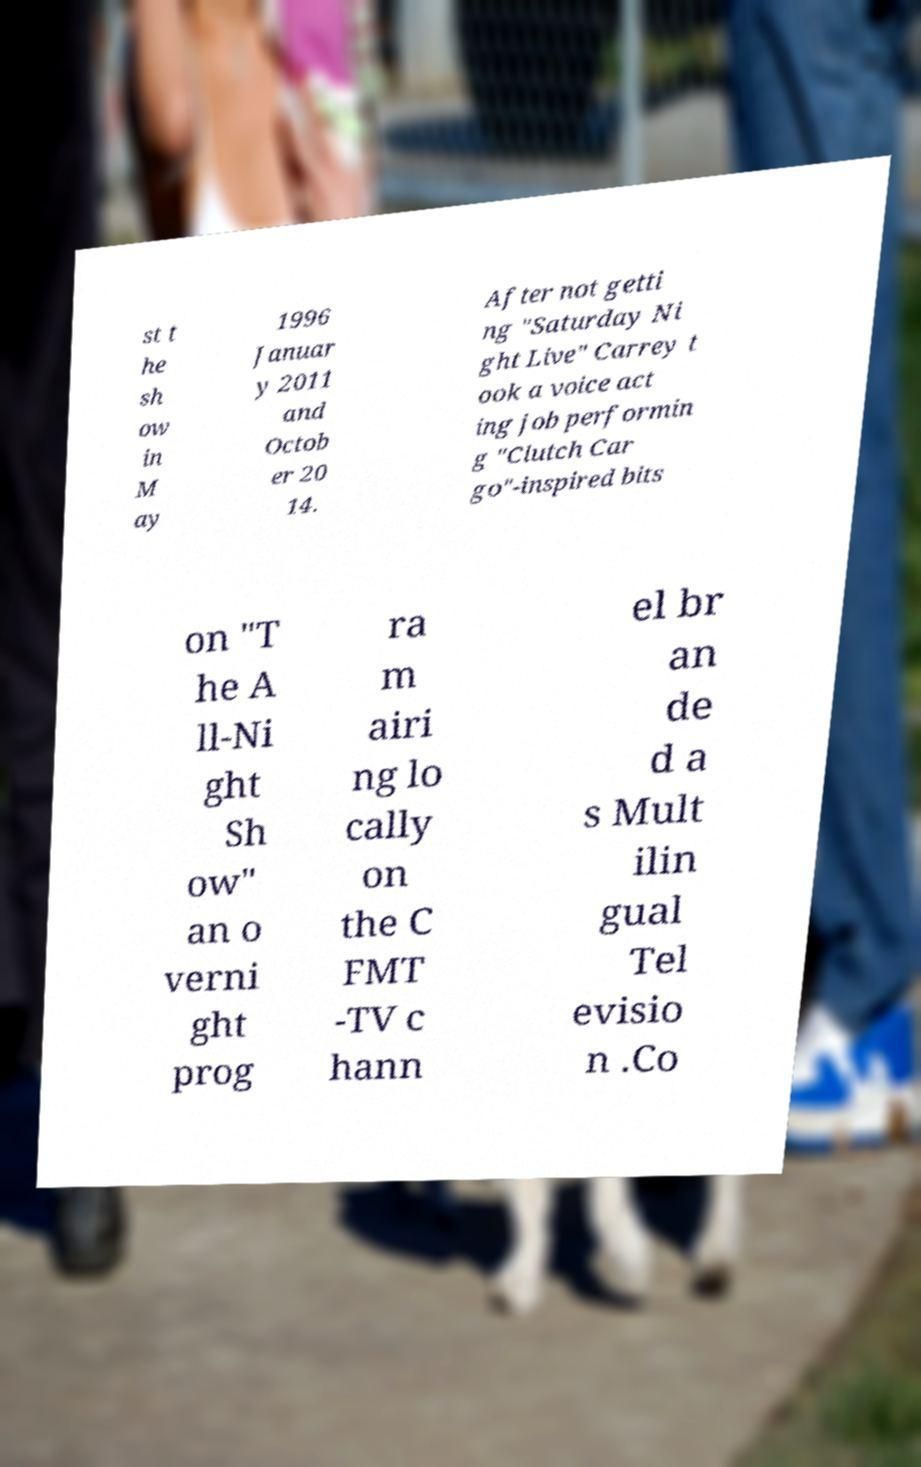For documentation purposes, I need the text within this image transcribed. Could you provide that? st t he sh ow in M ay 1996 Januar y 2011 and Octob er 20 14. After not getti ng "Saturday Ni ght Live" Carrey t ook a voice act ing job performin g "Clutch Car go"-inspired bits on "T he A ll-Ni ght Sh ow" an o verni ght prog ra m airi ng lo cally on the C FMT -TV c hann el br an de d a s Mult ilin gual Tel evisio n .Co 